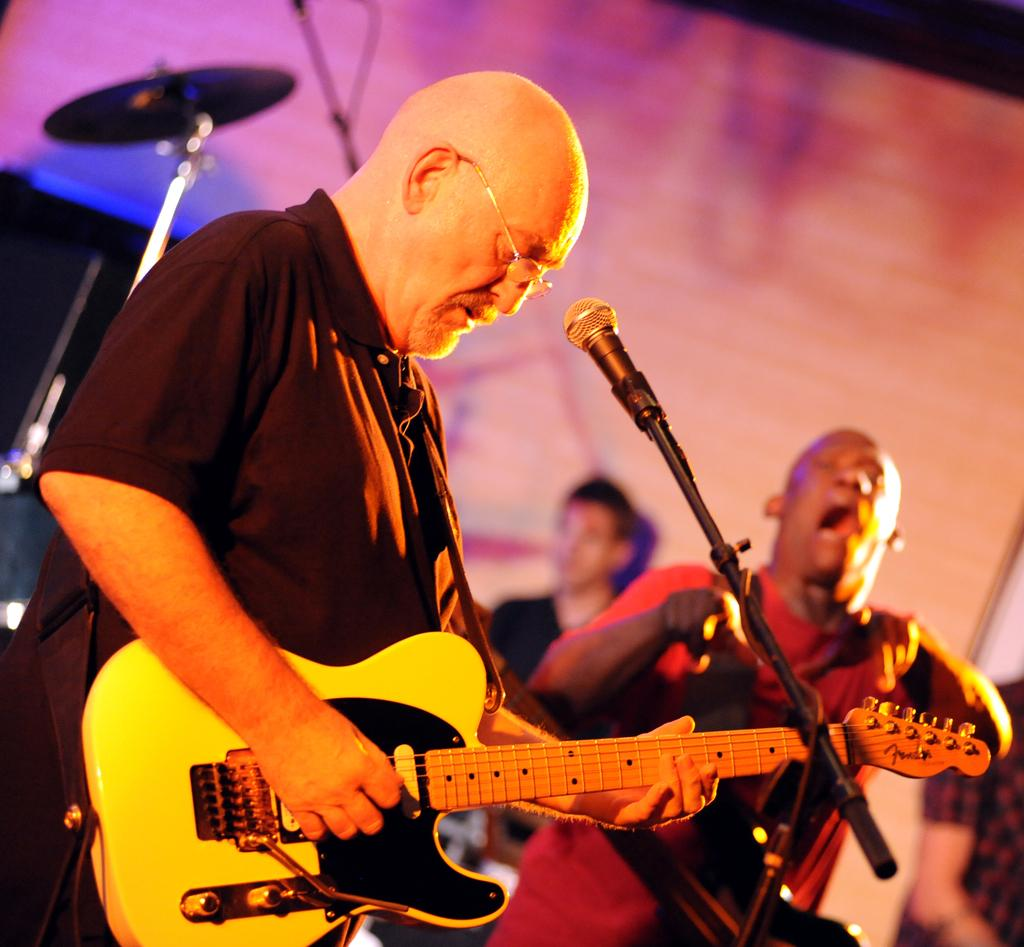What is the person in the image holding? The person in the image is holding a guitar. What is the person holding the guitar standing near? The person holding the guitar is standing in front of a microphone. Can you describe the actions of the second person in the image? The second person in the image is dancing and singing. What type of creature is playing the guitar in the image? There is no creature present in the image; it features a person holding a guitar. What scene is taking place in the image? The image does not depict a specific scene, but rather shows a person holding a guitar and another person dancing and singing. 